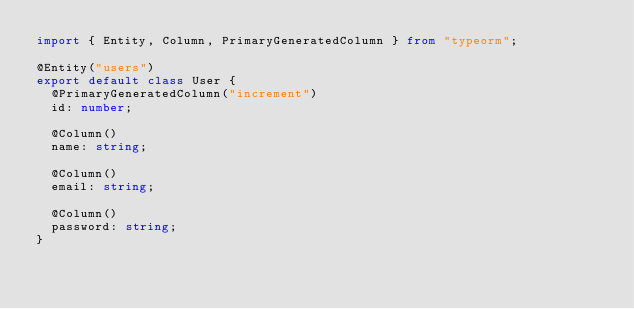Convert code to text. <code><loc_0><loc_0><loc_500><loc_500><_TypeScript_>import { Entity, Column, PrimaryGeneratedColumn } from "typeorm";

@Entity("users")
export default class User {
  @PrimaryGeneratedColumn("increment")
  id: number;

  @Column()
  name: string;

  @Column()
  email: string;

  @Column()
  password: string;
}
</code> 